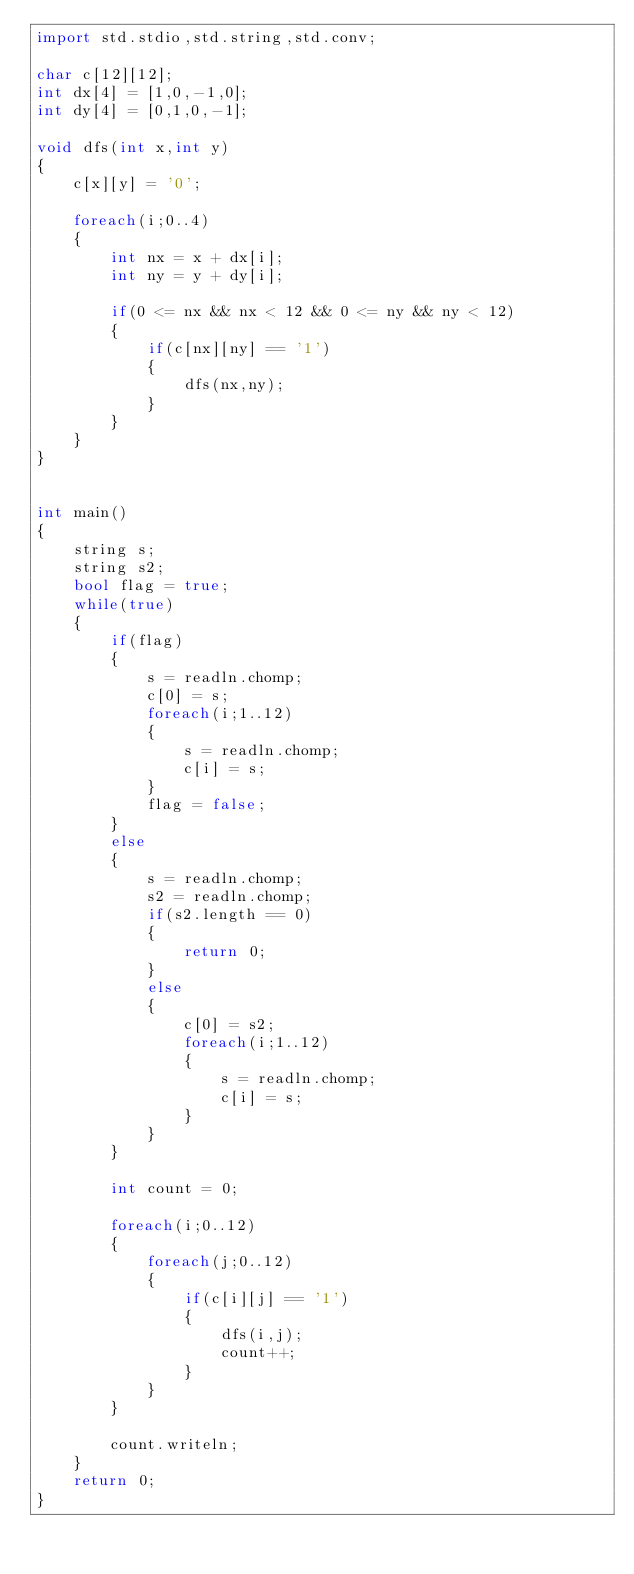Convert code to text. <code><loc_0><loc_0><loc_500><loc_500><_D_>import std.stdio,std.string,std.conv;

char c[12][12]; 
int dx[4] = [1,0,-1,0];
int dy[4] = [0,1,0,-1];

void dfs(int x,int y)
{
	c[x][y] = '0';

	foreach(i;0..4)
	{
		int nx = x + dx[i];
		int ny = y + dy[i];

		if(0 <= nx && nx < 12 && 0 <= ny && ny < 12)
		{
			if(c[nx][ny] == '1')
			{
				dfs(nx,ny);
			}
		}
	}
}


int main()
{
	string s;
	string s2;
	bool flag = true;
	while(true)
	{
		if(flag)
		{
			s = readln.chomp;
			c[0] = s;
			foreach(i;1..12)
			{
				s = readln.chomp;
				c[i] = s;
			}
			flag = false;
		}
		else
		{
			s = readln.chomp;
			s2 = readln.chomp;
			if(s2.length == 0)
			{
				return 0;
			}
			else
			{
				c[0] = s2;
				foreach(i;1..12)
				{
					s = readln.chomp;
					c[i] = s;
				}
			}
		}

		int count = 0;

		foreach(i;0..12)
		{
			foreach(j;0..12)
			{
				if(c[i][j] == '1')
				{
					dfs(i,j);
					count++;
				}
			}
		}

		count.writeln;
	}
	return 0;
}</code> 